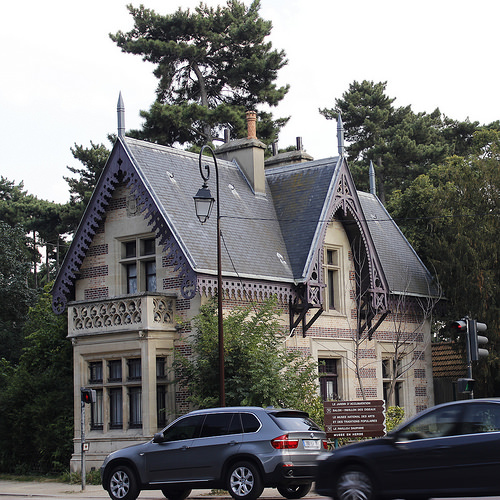<image>
Is there a car on the road? Yes. Looking at the image, I can see the car is positioned on top of the road, with the road providing support. Is the car in front of the house? Yes. The car is positioned in front of the house, appearing closer to the camera viewpoint. 